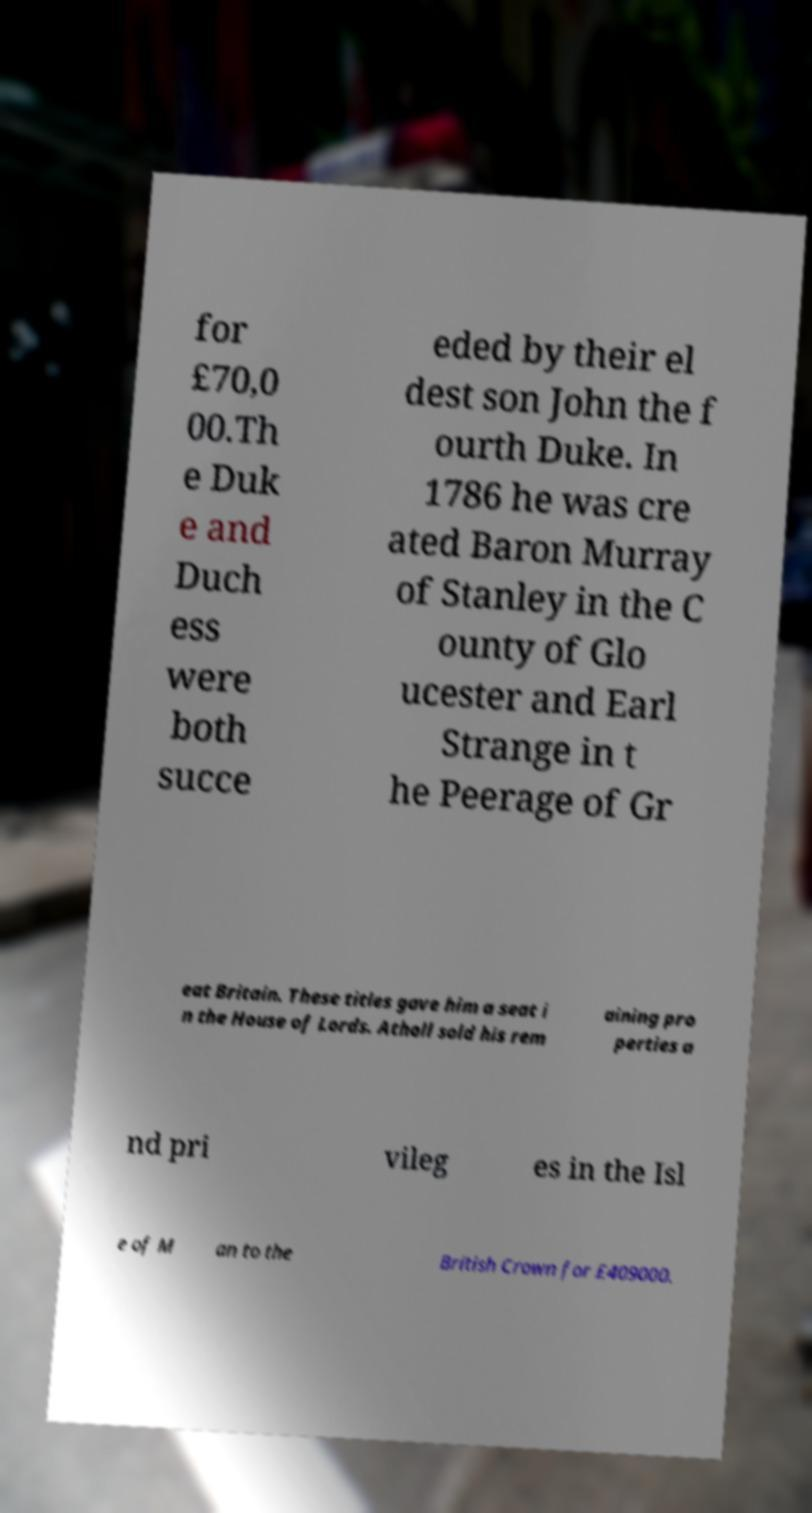Please identify and transcribe the text found in this image. for £70,0 00.Th e Duk e and Duch ess were both succe eded by their el dest son John the f ourth Duke. In 1786 he was cre ated Baron Murray of Stanley in the C ounty of Glo ucester and Earl Strange in t he Peerage of Gr eat Britain. These titles gave him a seat i n the House of Lords. Atholl sold his rem aining pro perties a nd pri vileg es in the Isl e of M an to the British Crown for £409000. 